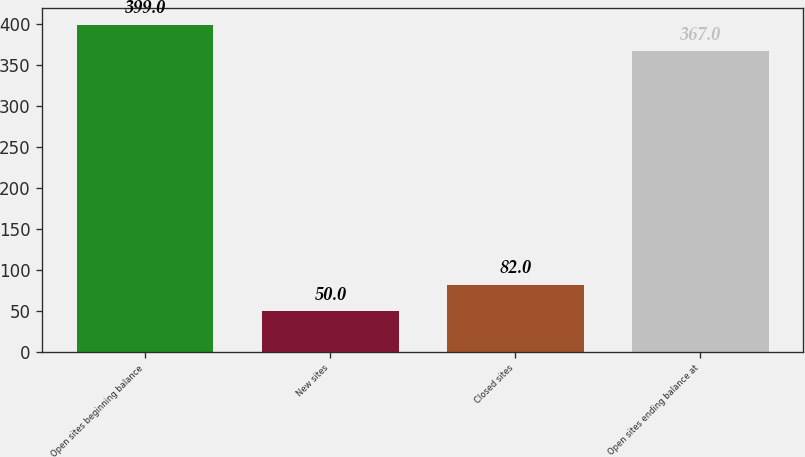Convert chart to OTSL. <chart><loc_0><loc_0><loc_500><loc_500><bar_chart><fcel>Open sites beginning balance<fcel>New sites<fcel>Closed sites<fcel>Open sites ending balance at<nl><fcel>399<fcel>50<fcel>82<fcel>367<nl></chart> 